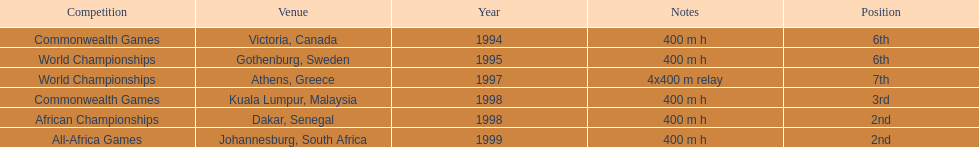Which year witnessed the highest number of competitions? 1998. 